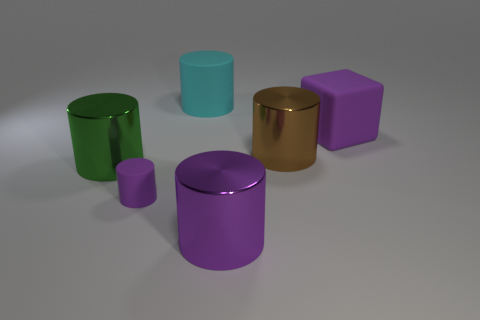Subtract all purple rubber cylinders. How many cylinders are left? 4 Subtract all brown cylinders. How many cylinders are left? 4 Subtract all red cylinders. Subtract all red cubes. How many cylinders are left? 5 Add 1 big purple cylinders. How many objects exist? 7 Subtract all cubes. How many objects are left? 5 Add 5 tiny purple rubber cylinders. How many tiny purple rubber cylinders exist? 6 Subtract 0 brown spheres. How many objects are left? 6 Subtract all green cylinders. Subtract all purple rubber cubes. How many objects are left? 4 Add 6 large purple cylinders. How many large purple cylinders are left? 7 